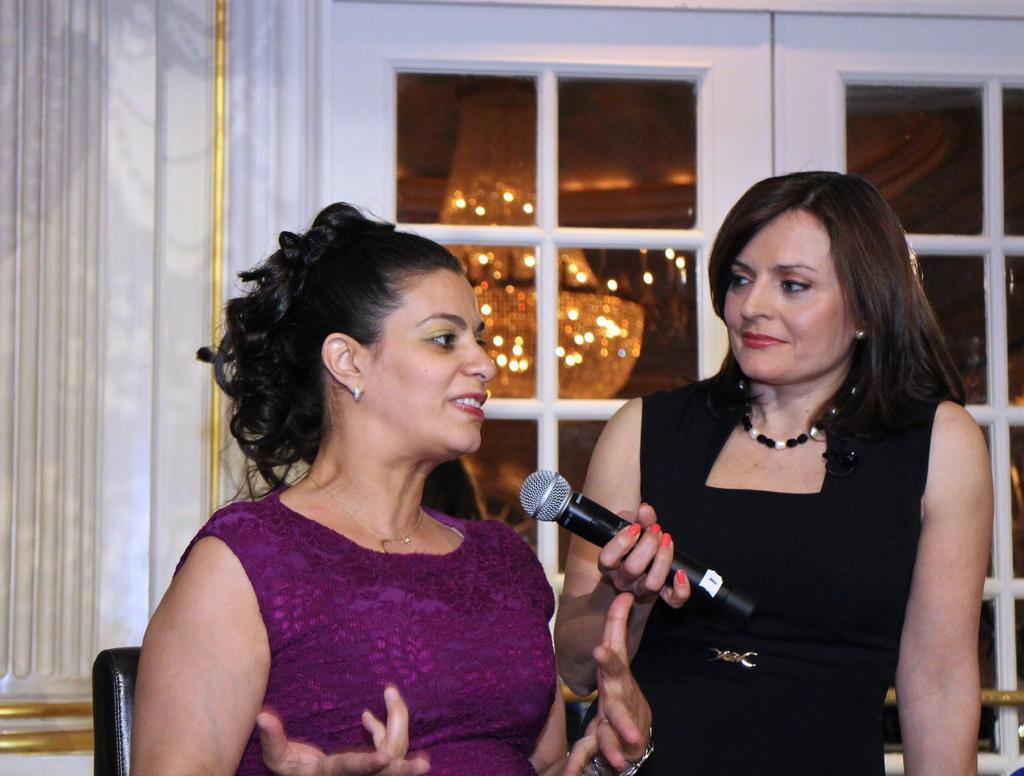How many women are in the image? There are two women in the image. What is the position of the woman on the left side? The woman on the left side is seated on a chair. What is the woman on the right side holding? The woman on the right side is holding a microphone. What can be seen in the background of the image? There is a light visible in the background of the image. What type of stew is being prepared by the women in the image? There is no indication of any stew being prepared in the image; the women are focused on the microphone and chair. 